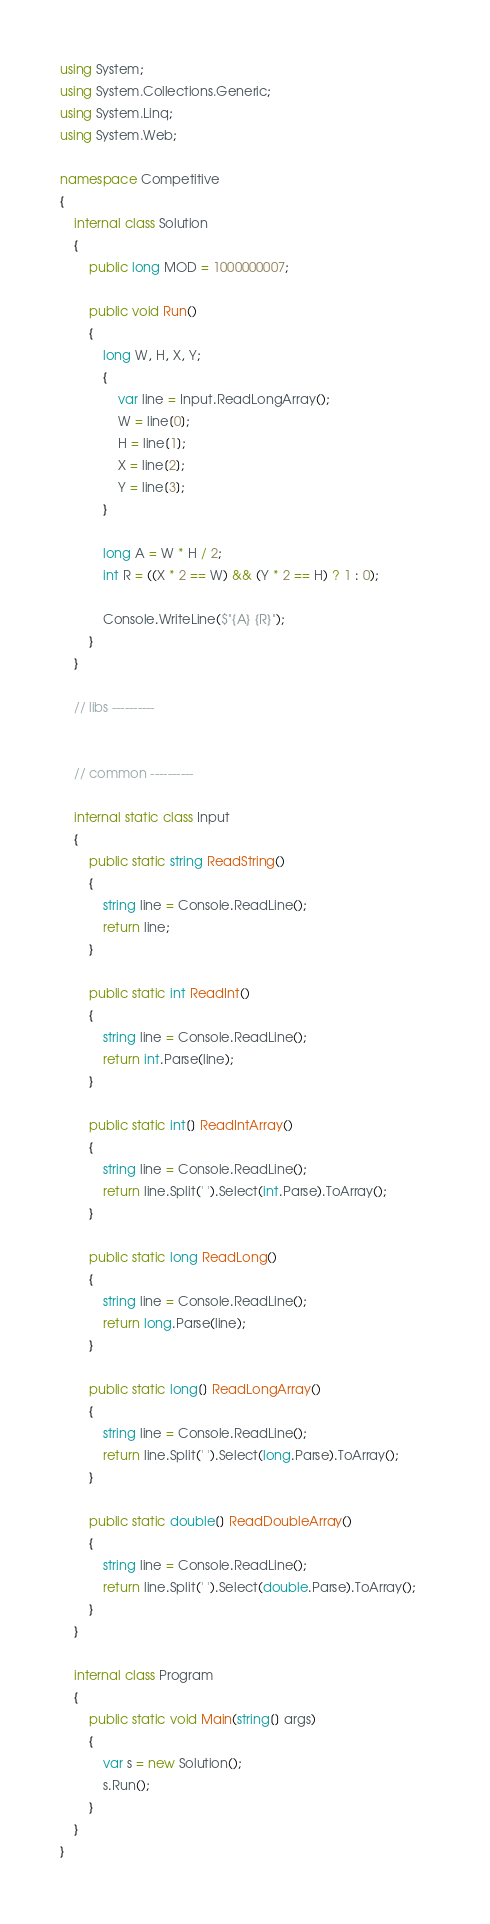<code> <loc_0><loc_0><loc_500><loc_500><_C#_>using System;
using System.Collections.Generic;
using System.Linq;
using System.Web;

namespace Competitive
{
    internal class Solution
    {
        public long MOD = 1000000007;

        public void Run()
        {
            long W, H, X, Y;
            {
                var line = Input.ReadLongArray();
                W = line[0];
                H = line[1];
                X = line[2];
                Y = line[3];
            }

            long A = W * H / 2;
            int R = ((X * 2 == W) && (Y * 2 == H) ? 1 : 0);
            
            Console.WriteLine($"{A} {R}");
        }
    }

    // libs ----------
    

    // common ----------

    internal static class Input
    {
        public static string ReadString()
        {
            string line = Console.ReadLine();
            return line;
        }

        public static int ReadInt()
        {
            string line = Console.ReadLine();
            return int.Parse(line);
        }

        public static int[] ReadIntArray()
        {
            string line = Console.ReadLine();
            return line.Split(' ').Select(int.Parse).ToArray();            
        }

        public static long ReadLong()
        {
            string line = Console.ReadLine();
            return long.Parse(line);
        }

        public static long[] ReadLongArray()
        {
            string line = Console.ReadLine();
            return line.Split(' ').Select(long.Parse).ToArray();
        }

        public static double[] ReadDoubleArray()
        {
            string line = Console.ReadLine();
            return line.Split(' ').Select(double.Parse).ToArray();
        }
    }
    
    internal class Program
    {
        public static void Main(string[] args)
        {
            var s = new Solution();
            s.Run();
        }
    }
}</code> 